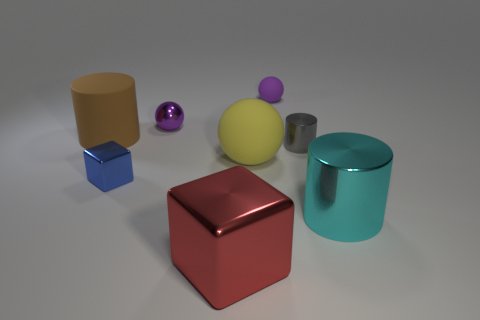What number of other things are the same color as the big shiny cylinder? Upon reviewing the colors of various items in the image, it appears that none of the other objects share the exact shade of the large, shiny teal cylinder. 